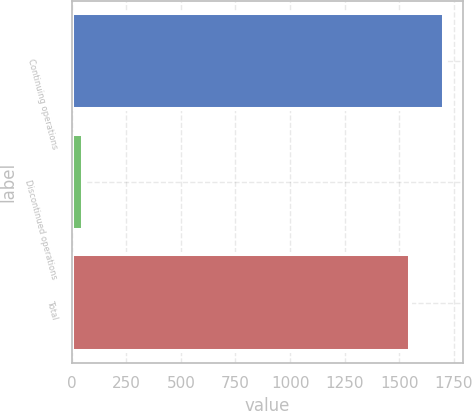<chart> <loc_0><loc_0><loc_500><loc_500><bar_chart><fcel>Continuing operations<fcel>Discontinued operations<fcel>Total<nl><fcel>1705<fcel>51<fcel>1550<nl></chart> 